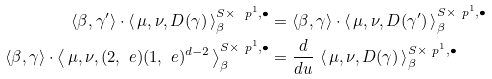<formula> <loc_0><loc_0><loc_500><loc_500>\langle \beta , \gamma ^ { \prime } \rangle \cdot \left \langle \, \mu , \nu , D ( \gamma ) \, \right \rangle _ { \beta } ^ { S \times \ p ^ { 1 } , \bullet } & = \langle \beta , \gamma \rangle \cdot \left \langle \, \mu , \nu , D ( \gamma ^ { \prime } ) \, \right \rangle _ { \beta } ^ { S \times \ p ^ { 1 } , \bullet } \\ \langle \beta , \gamma \rangle \cdot \left \langle \, \mu , \nu , ( 2 , \ e ) ( 1 , \ e ) ^ { d - 2 } \, \right \rangle _ { \beta } ^ { S \times \ p ^ { 1 } , \bullet } & = \frac { d } { d u } \, \left \langle \, \mu , \nu , D ( \gamma ) \, \right \rangle _ { \beta } ^ { S \times \ p ^ { 1 } , \bullet }</formula> 